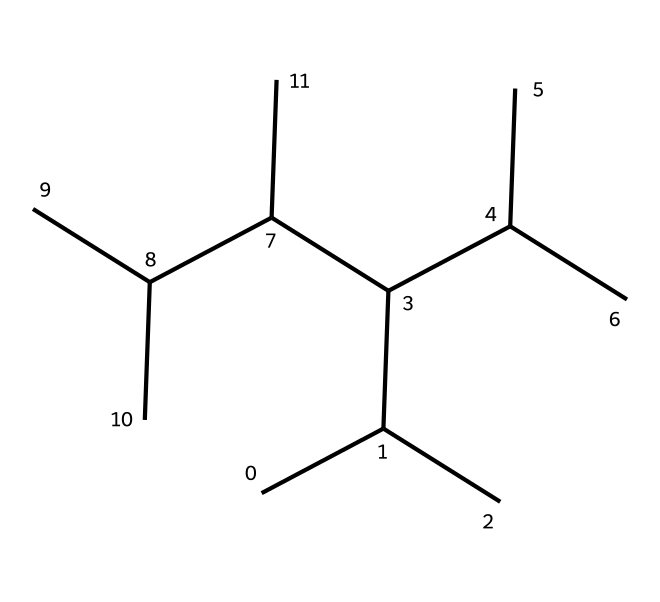What is the main repeating unit in this polymer? The SMILES representation indicates multiple carbon branches, which suggests a structure characteristic of polypropylene, where the main repeating unit contains propylene (C3H6) as the backbone.
Answer: polypropylene How many carbon atoms are present in this molecule? By analyzing the SMILES, we can count the total number of carbon atoms represented in the structure, which reveals that there are 12 carbon atoms.
Answer: 12 What type of bonding is primarily involved in this polymer’s structure? The polymer is made up of carbon atoms connected primarily through single covalent bonds (sigma bonds), which is typical for saturated hydrocarbons like polypropylene.
Answer: covalent How does the branched structure affect its sound absorption properties? The branched structure increases the material's surface area and alters its density, which are crucial factors in enhancing sound absorption by minimizing sound transmission through the material.
Answer: increases surface area What is the primary use of polypropylene in acoustics? This polymer is primarily used in sound-absorbing panels because of its lightweight properties and effectiveness in minimizing sound reflection and transmission, which enhances acoustic performance.
Answer: sound-absorbing panels Does this polymer exhibit crystallinity? Polypropylene can exhibit both crystalline and amorphous characteristics depending on the molecular arrangement; the branched nature can make it more amorphous, affecting its mechanical properties.
Answer: both What is the thermal property of this polymer in terms of sound insulation? Polypropylene has a relatively low thermal conductivity, allowing it to retain heat while also minimizing sound transmission, hence acting effectively as both an insulator and sound absorber.
Answer: low thermal conductivity 